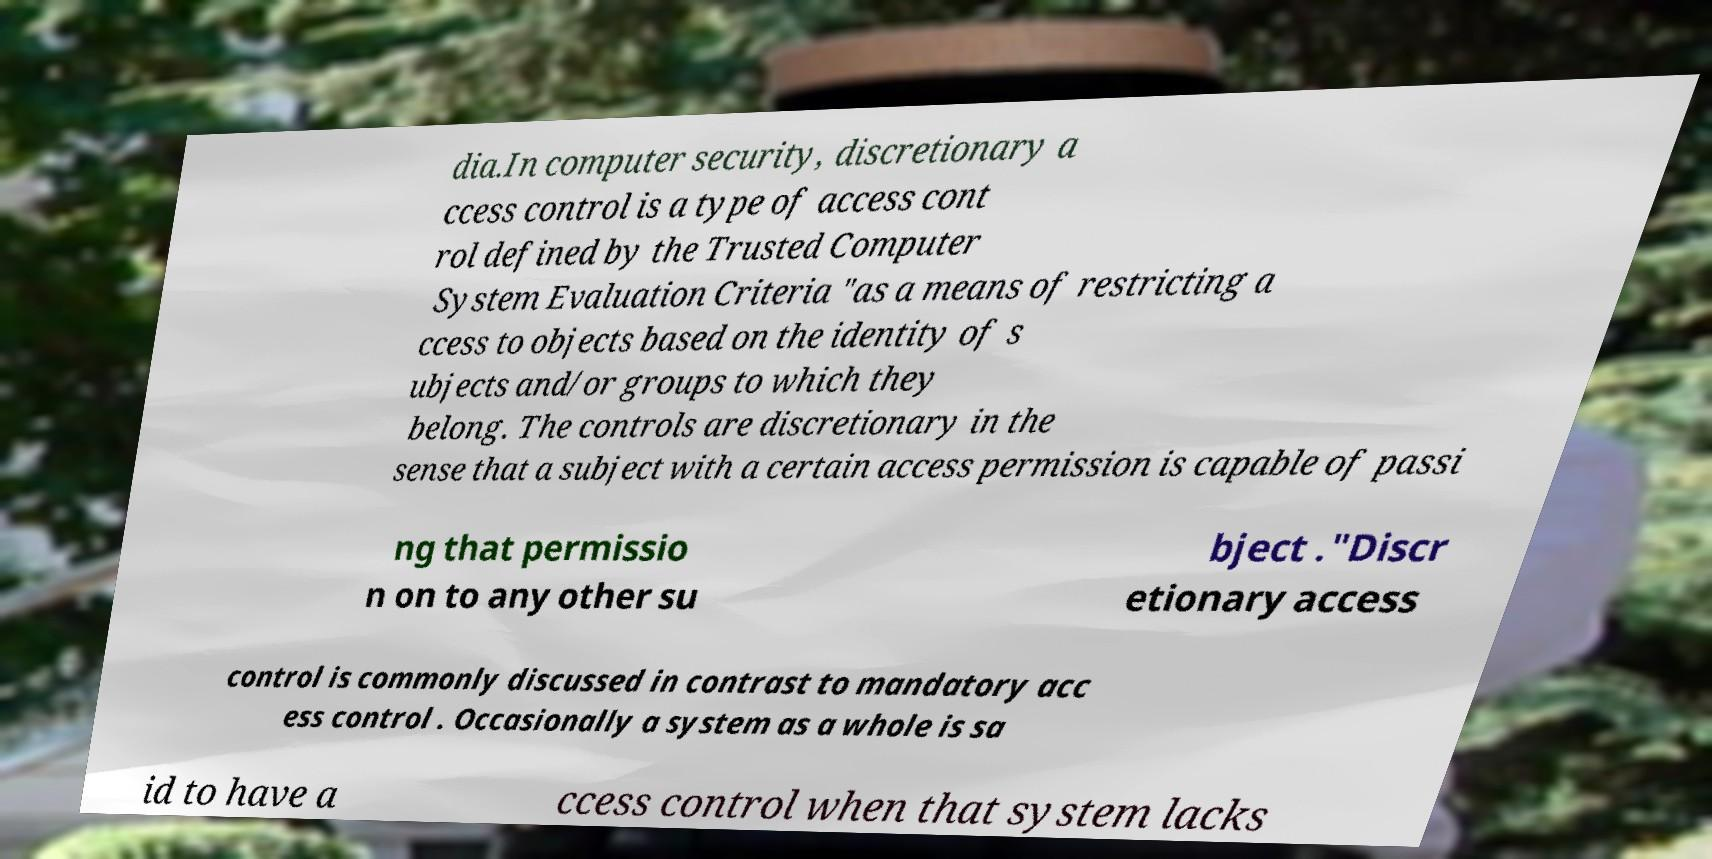Please read and relay the text visible in this image. What does it say? dia.In computer security, discretionary a ccess control is a type of access cont rol defined by the Trusted Computer System Evaluation Criteria "as a means of restricting a ccess to objects based on the identity of s ubjects and/or groups to which they belong. The controls are discretionary in the sense that a subject with a certain access permission is capable of passi ng that permissio n on to any other su bject ."Discr etionary access control is commonly discussed in contrast to mandatory acc ess control . Occasionally a system as a whole is sa id to have a ccess control when that system lacks 